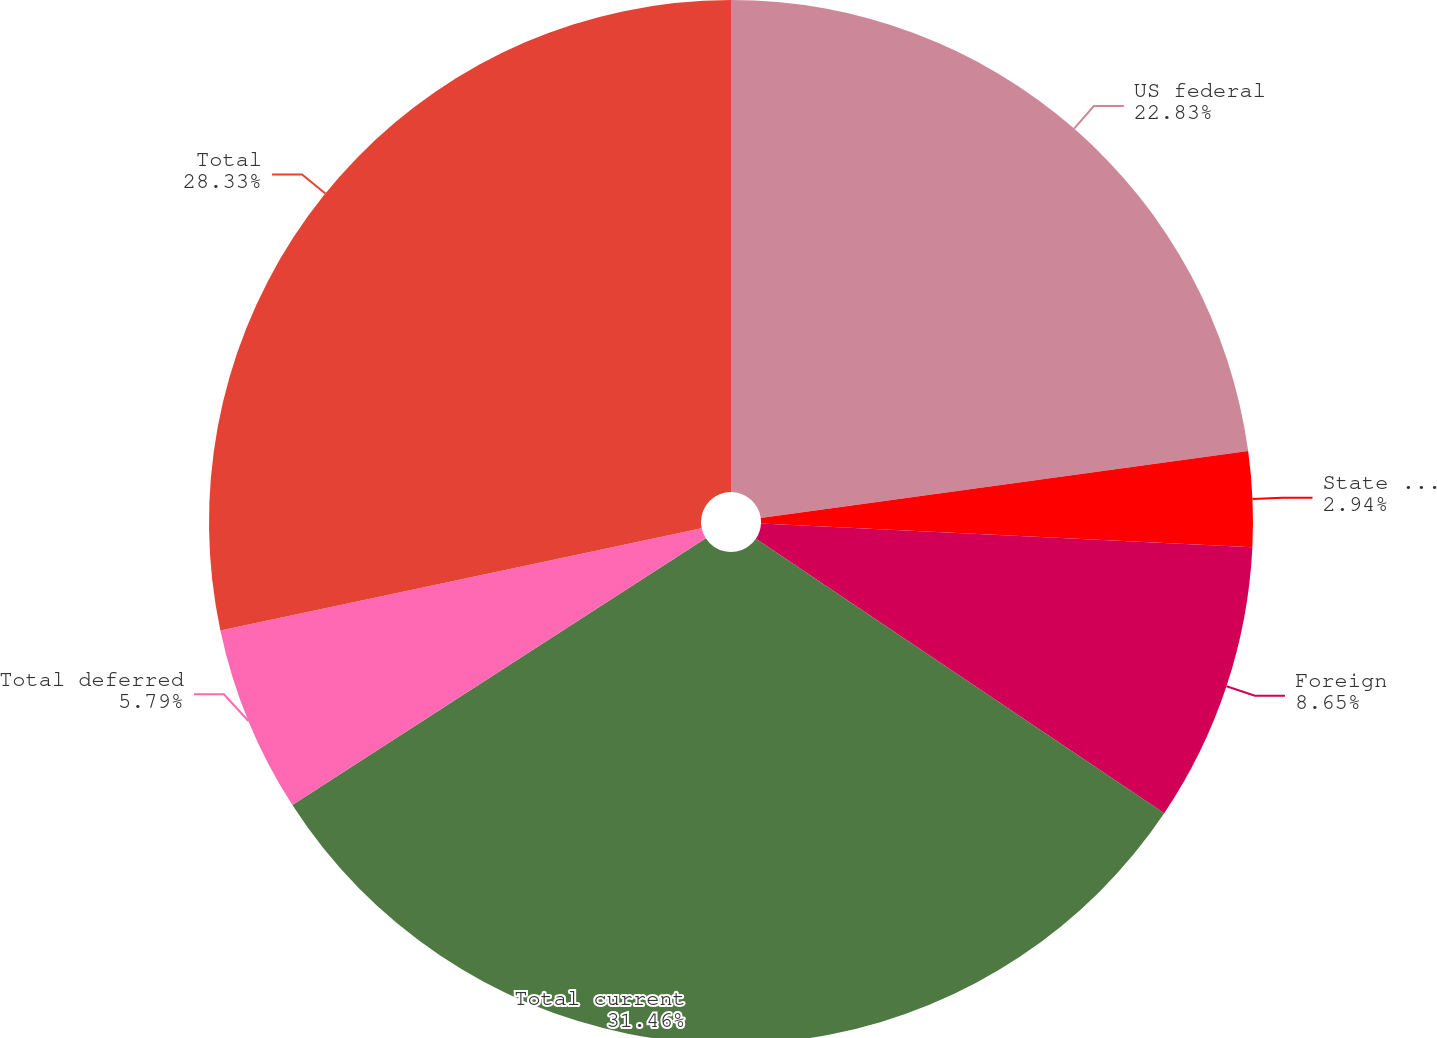Convert chart to OTSL. <chart><loc_0><loc_0><loc_500><loc_500><pie_chart><fcel>US federal<fcel>State and local<fcel>Foreign<fcel>Total current<fcel>Total deferred<fcel>Total<nl><fcel>22.83%<fcel>2.94%<fcel>8.65%<fcel>31.46%<fcel>5.79%<fcel>28.33%<nl></chart> 